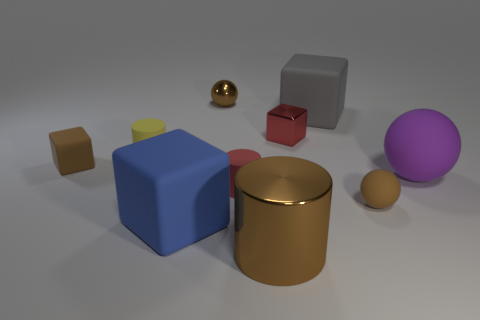Subtract all big gray rubber blocks. How many blocks are left? 3 Subtract 2 blocks. How many blocks are left? 2 Subtract all gray cubes. How many cubes are left? 3 Subtract all cyan blocks. Subtract all green cylinders. How many blocks are left? 4 Subtract all spheres. How many objects are left? 7 Add 1 brown balls. How many brown balls are left? 3 Add 5 red metallic cubes. How many red metallic cubes exist? 6 Subtract 1 blue cubes. How many objects are left? 9 Subtract all yellow matte things. Subtract all blue blocks. How many objects are left? 8 